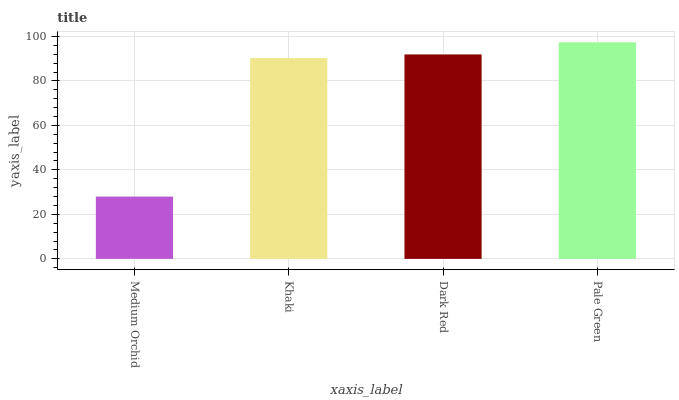Is Medium Orchid the minimum?
Answer yes or no. Yes. Is Pale Green the maximum?
Answer yes or no. Yes. Is Khaki the minimum?
Answer yes or no. No. Is Khaki the maximum?
Answer yes or no. No. Is Khaki greater than Medium Orchid?
Answer yes or no. Yes. Is Medium Orchid less than Khaki?
Answer yes or no. Yes. Is Medium Orchid greater than Khaki?
Answer yes or no. No. Is Khaki less than Medium Orchid?
Answer yes or no. No. Is Dark Red the high median?
Answer yes or no. Yes. Is Khaki the low median?
Answer yes or no. Yes. Is Pale Green the high median?
Answer yes or no. No. Is Dark Red the low median?
Answer yes or no. No. 